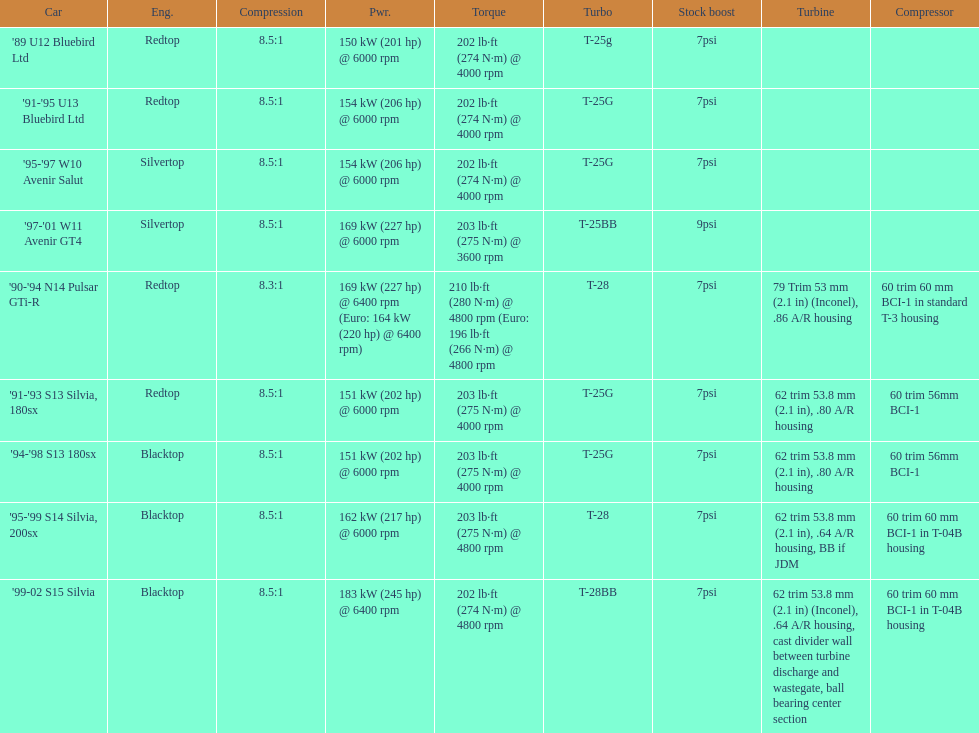Which engines are the same as the first entry ('89 u12 bluebird ltd)? '91-'95 U13 Bluebird Ltd, '90-'94 N14 Pulsar GTi-R, '91-'93 S13 Silvia, 180sx. 